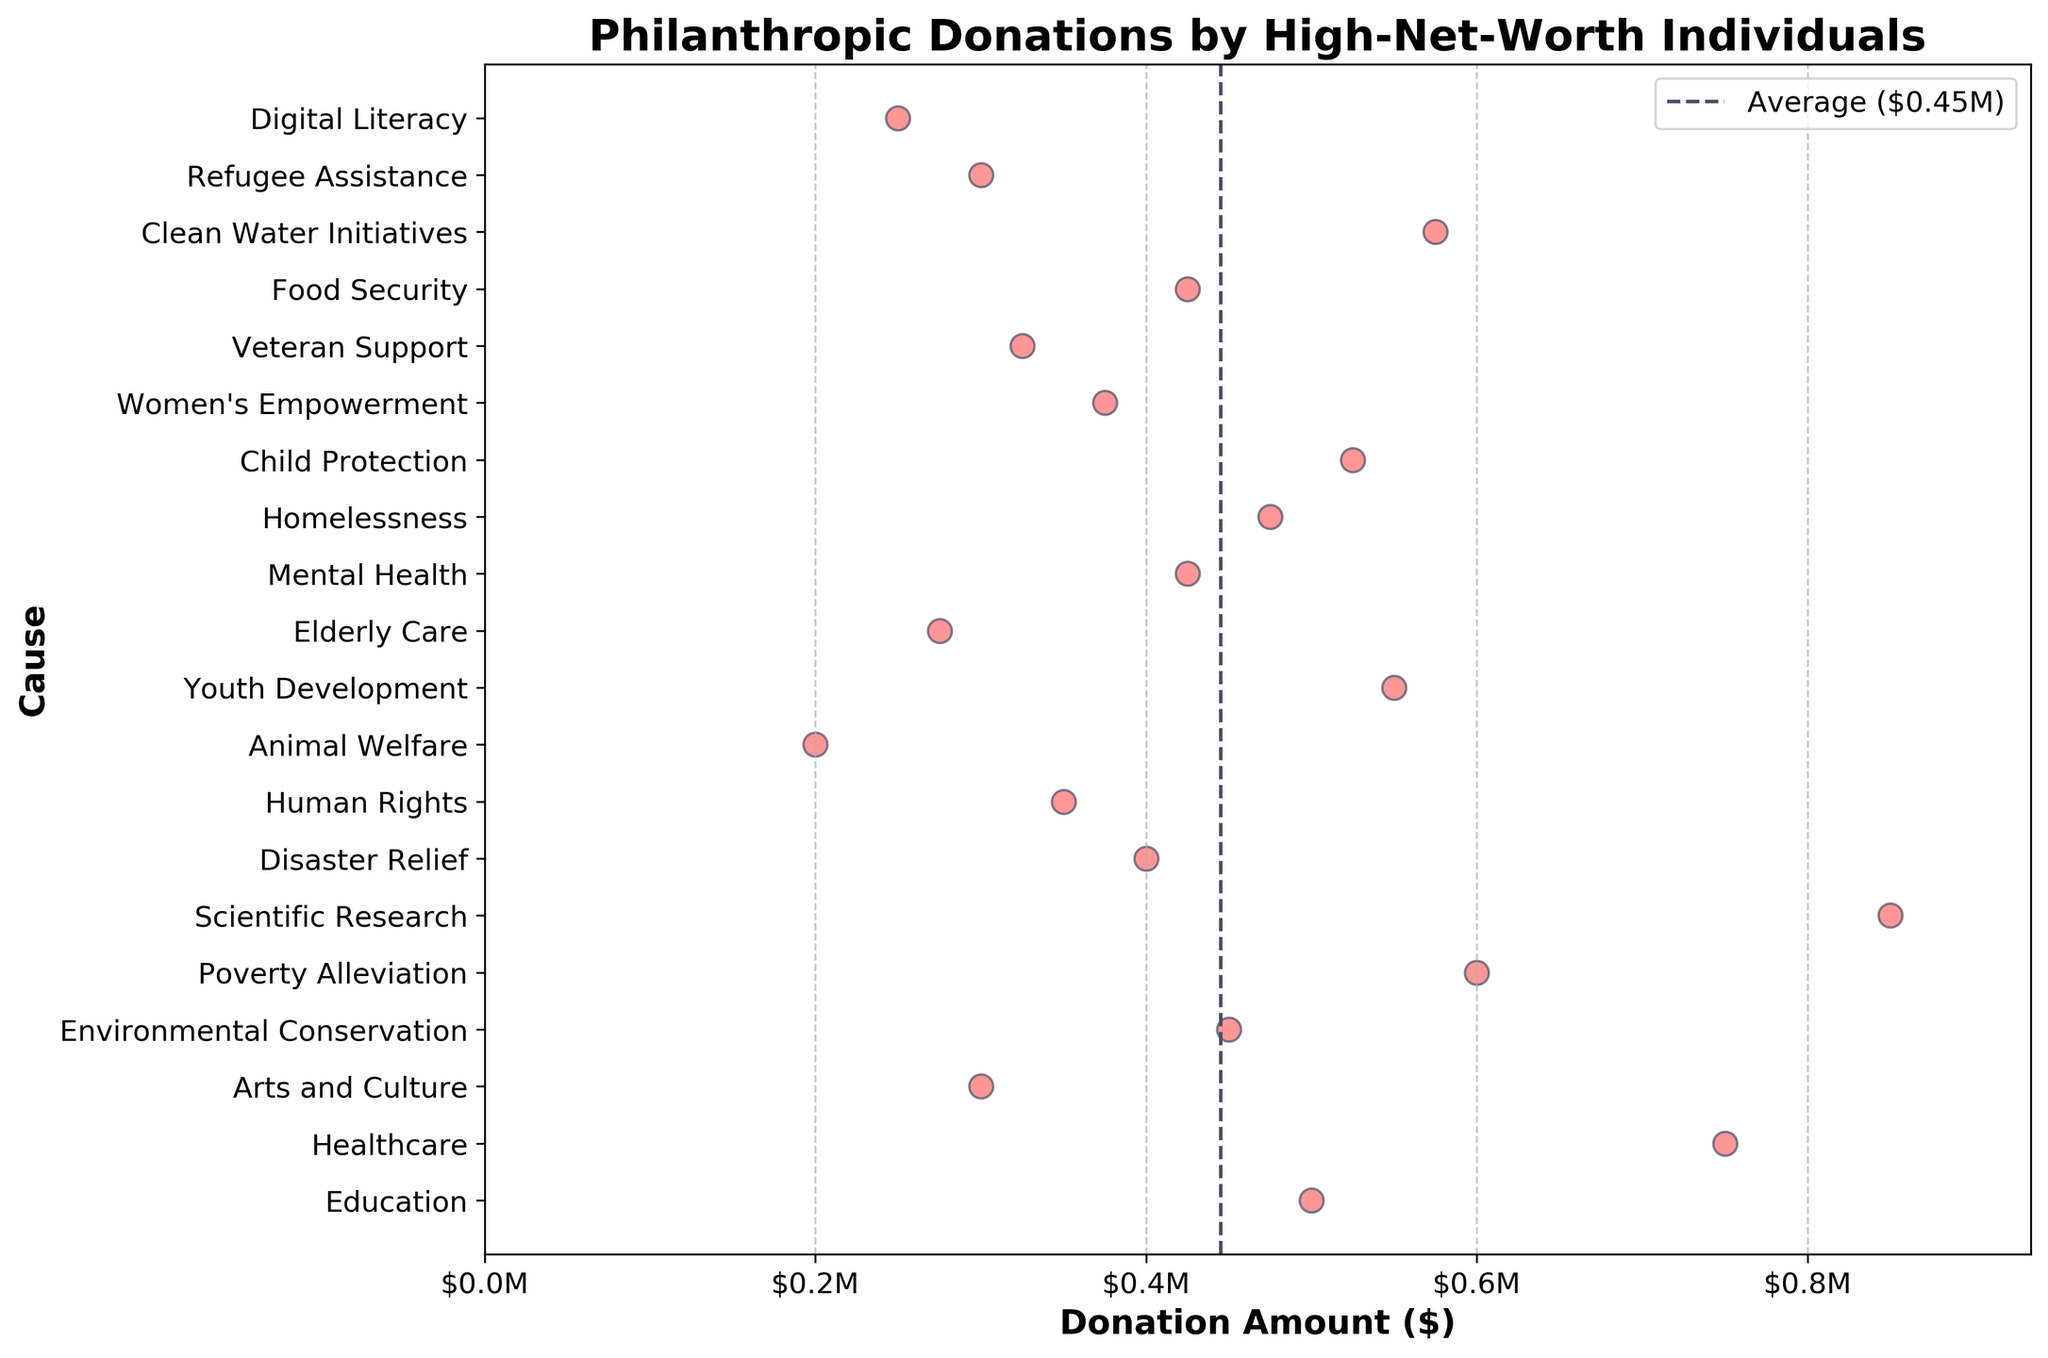What is the title of the plot? The title is displayed at the top of the figure. It summarizes the main topic of the plot.
Answer: Philanthropic Donations by High-Net-Worth Individuals What is the average donation amount indicated by the vertical line? The vertical line represents the average donation amount. It is drawn at the donation value which visually approximates the central tendency of the donations.
Answer: $450,000 How many causes fall below the average donation amount? By observing the position of the causes relative to the average line, we can count the number of causes with donation amounts less than the average line value.
Answer: 11 What is the range of donation amounts for the different causes? By looking at the scatter plot from the minimum to the maximum donation value, we can determine the range. The minimum donation is 200,000, and the maximum is 850,000.
Answer: $200,000 to $850,000 Which cause has the highest donation amount? By identifying the highest dot along the x-axis representing donation amounts, we can find the cause with the highest donation.
Answer: Scientific Research Which cause has the lowest donation amount? By identifying the lowest dot along the x-axis representing donation amounts, we can find the cause with the lowest donation.
Answer: Animal Welfare What percentage of the causes have donation amounts of $500,000 or more? Count the number of causes with donation amounts equal to or greater than 500,000 and divide by the total number of causes, then multiply by 100 to get the percentage.
Answer: 50% How do donations towards Environmental Conservation compare to those towards Healthcare? By comparing the positions of Environmental Conservation and Healthcare along the x-axis, we can see that donations towards Healthcare are larger.
Answer: Healthcare has higher donations What insights can be derived from the clustering of donation amounts on the plot? The clustering shows us the distribution and tendencies of donation sizes across different causes. Clusters around the average line indicate common donation amounts, while isolated points show special preference.
Answer: Most donations cluster around $400,000 - $600,000 How many causes have a donation amount within $100,000 of the average donation amount? Count the number of causes with donation amounts between 350,000 and 550,000. These causes are within $100,000 above or below the average amount of $450,000.
Answer: 7 